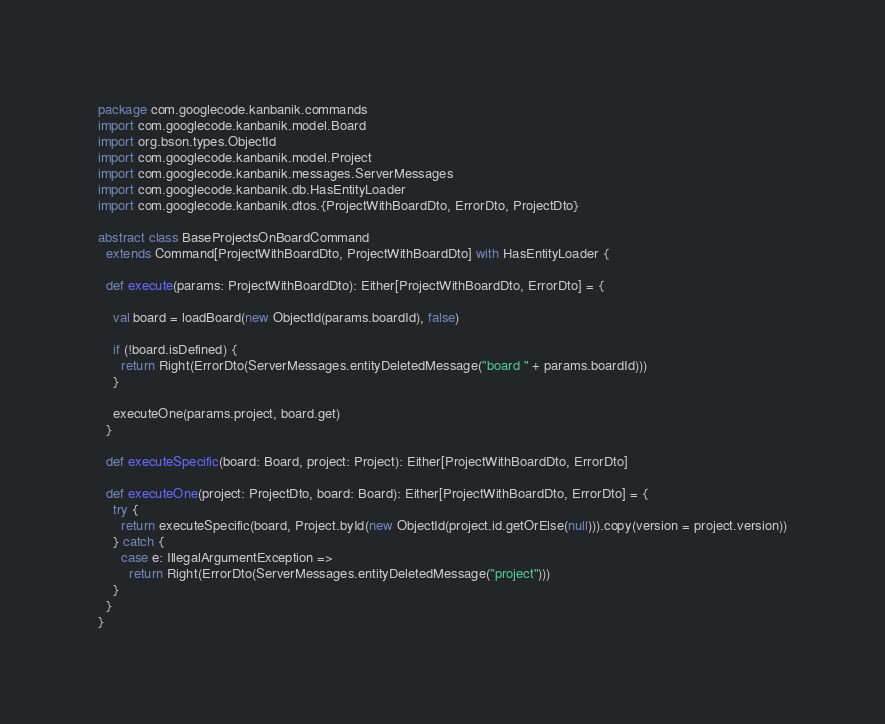<code> <loc_0><loc_0><loc_500><loc_500><_Scala_>package com.googlecode.kanbanik.commands
import com.googlecode.kanbanik.model.Board
import org.bson.types.ObjectId
import com.googlecode.kanbanik.model.Project
import com.googlecode.kanbanik.messages.ServerMessages
import com.googlecode.kanbanik.db.HasEntityLoader
import com.googlecode.kanbanik.dtos.{ProjectWithBoardDto, ErrorDto, ProjectDto}

abstract class BaseProjectsOnBoardCommand
  extends Command[ProjectWithBoardDto, ProjectWithBoardDto] with HasEntityLoader {

  def execute(params: ProjectWithBoardDto): Either[ProjectWithBoardDto, ErrorDto] = {

    val board = loadBoard(new ObjectId(params.boardId), false)

    if (!board.isDefined) {
      return Right(ErrorDto(ServerMessages.entityDeletedMessage("board " + params.boardId)))
    }

    executeOne(params.project, board.get)
  }

  def executeSpecific(board: Board, project: Project): Either[ProjectWithBoardDto, ErrorDto]

  def executeOne(project: ProjectDto, board: Board): Either[ProjectWithBoardDto, ErrorDto] = {
    try {
      return executeSpecific(board, Project.byId(new ObjectId(project.id.getOrElse(null))).copy(version = project.version))
    } catch {
      case e: IllegalArgumentException =>
        return Right(ErrorDto(ServerMessages.entityDeletedMessage("project")))
    }
  }
}

</code> 